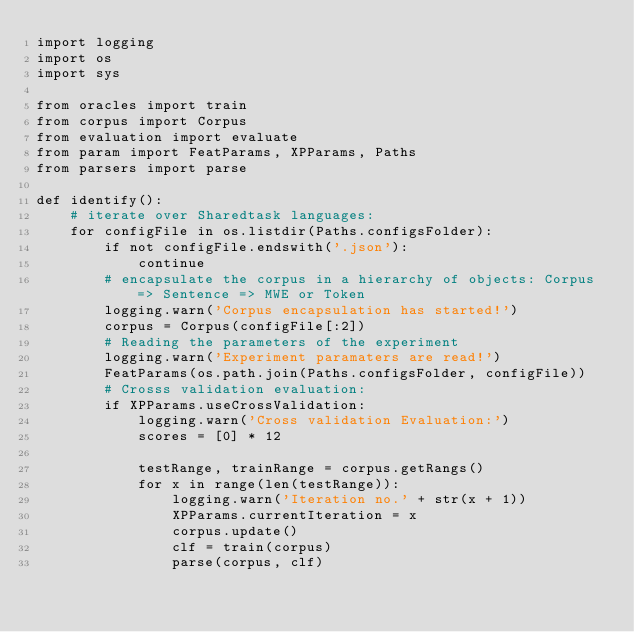<code> <loc_0><loc_0><loc_500><loc_500><_Python_>import logging
import os
import sys

from oracles import train
from corpus import Corpus
from evaluation import evaluate
from param import FeatParams, XPParams, Paths
from parsers import parse

def identify():
    # iterate over Sharedtask languages:
    for configFile in os.listdir(Paths.configsFolder):
        if not configFile.endswith('.json'):
            continue
        # encapsulate the corpus in a hierarchy of objects: Corpus => Sentence => MWE or Token
        logging.warn('Corpus encapsulation has started!')
        corpus = Corpus(configFile[:2])
        # Reading the parameters of the experiment
        logging.warn('Experiment paramaters are read!')
        FeatParams(os.path.join(Paths.configsFolder, configFile))
        # Crosss validation evaluation:
        if XPParams.useCrossValidation:
            logging.warn('Cross validation Evaluation:')
            scores = [0] * 12

            testRange, trainRange = corpus.getRangs()
            for x in range(len(testRange)):
                logging.warn('Iteration no.' + str(x + 1))
                XPParams.currentIteration = x
                corpus.update()
                clf = train(corpus)
                parse(corpus, clf)</code> 